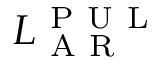<formula> <loc_0><loc_0><loc_500><loc_500>L _ { A R } ^ { P U L }</formula> 